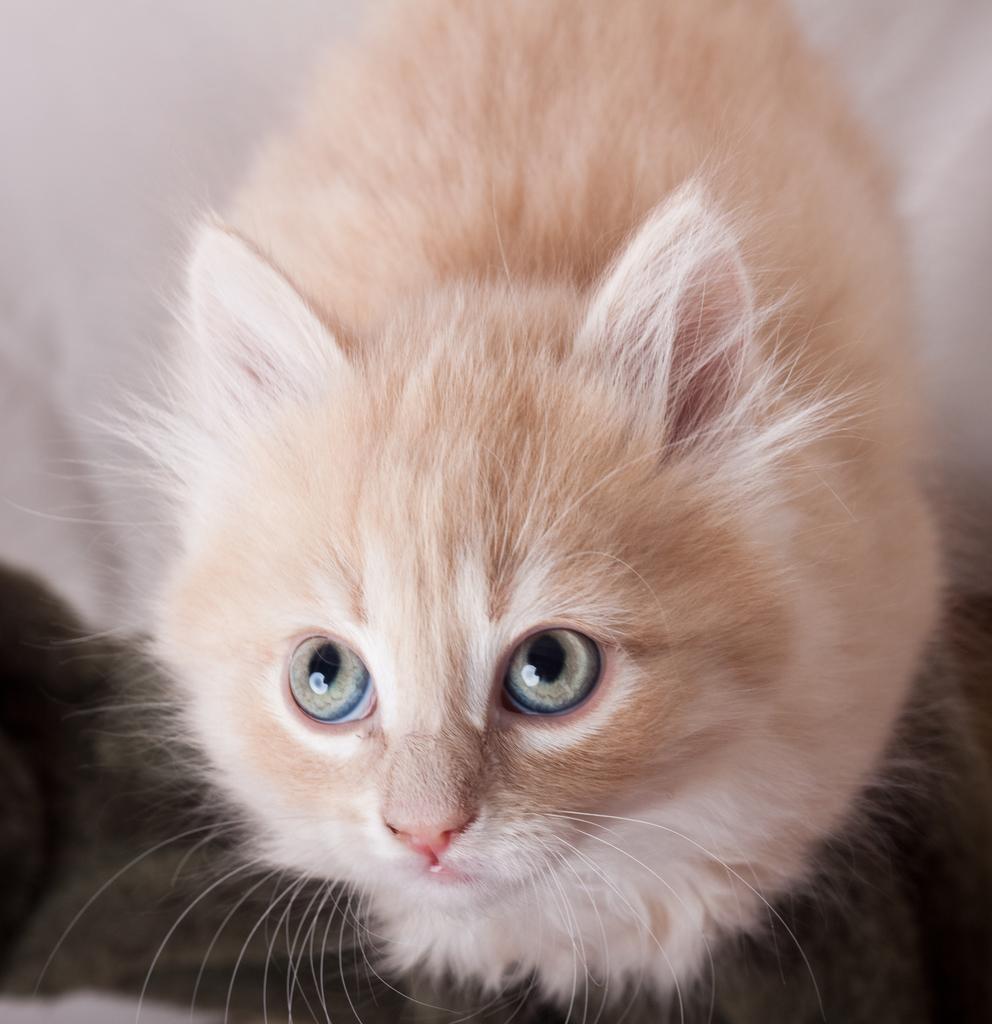Can you describe this image briefly? In this picture we can see a cat. 